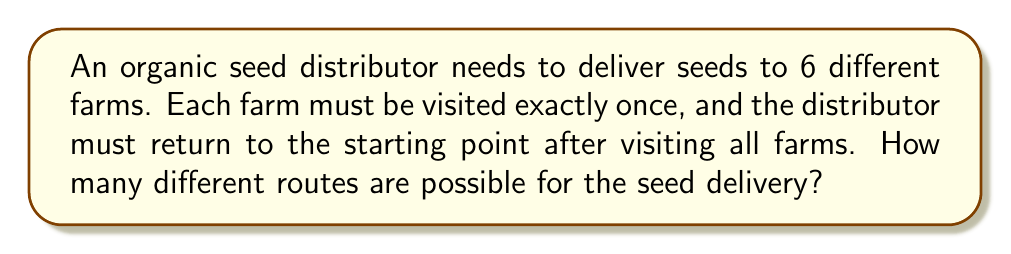Show me your answer to this math problem. Let's approach this step-by-step:

1) This problem is equivalent to finding the number of possible circular permutations of 6 farms.

2) For a regular permutation of n distinct objects, we would have n! possibilities.

3) However, in a circular permutation, rotations of the same arrangement are considered identical. For example, if we have farms A, B, C, D, E, F, the following are considered the same route:
   A → B → C → D → E → F → A
   B → C → D → E → F → A → B
   C → D → E → F → A → B → C
   and so on...

4) In fact, each unique circular permutation corresponds to (n-1)! regular permutations, where n is the number of farms.

5) Therefore, the number of unique circular permutations is:

   $$\frac{n!}{(n-1)!} = n$$

6) In this case, with 6 farms, the number of possible routes is:

   $$6! / 5! = 6 / 1 = 6$$

7) We can also arrive at this result by realizing that once we fix the starting point, we have 5! ways to arrange the remaining 5 farms.

Thus, there are 6 possible routes for the seed delivery.
Answer: 6 